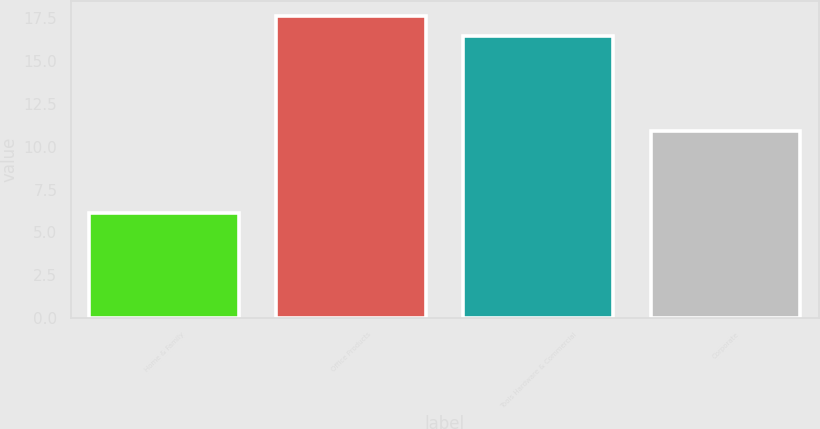Convert chart. <chart><loc_0><loc_0><loc_500><loc_500><bar_chart><fcel>Home & Family<fcel>Office Products<fcel>Tools Hardware & Commercial<fcel>Corporate<nl><fcel>6.1<fcel>17.64<fcel>16.5<fcel>10.9<nl></chart> 